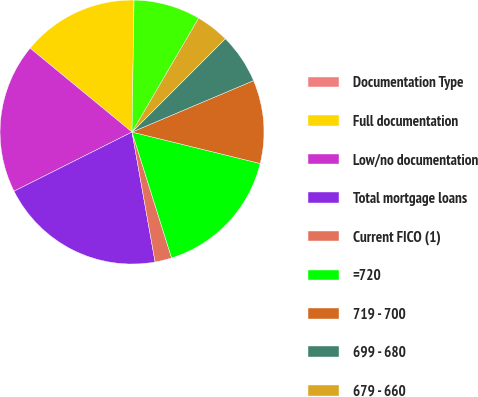<chart> <loc_0><loc_0><loc_500><loc_500><pie_chart><fcel>Documentation Type<fcel>Full documentation<fcel>Low/no documentation<fcel>Total mortgage loans<fcel>Current FICO (1)<fcel>=720<fcel>719 - 700<fcel>699 - 680<fcel>679 - 660<fcel>659 - 620<nl><fcel>0.01%<fcel>14.28%<fcel>18.36%<fcel>20.4%<fcel>2.05%<fcel>16.32%<fcel>10.2%<fcel>6.13%<fcel>4.09%<fcel>8.16%<nl></chart> 